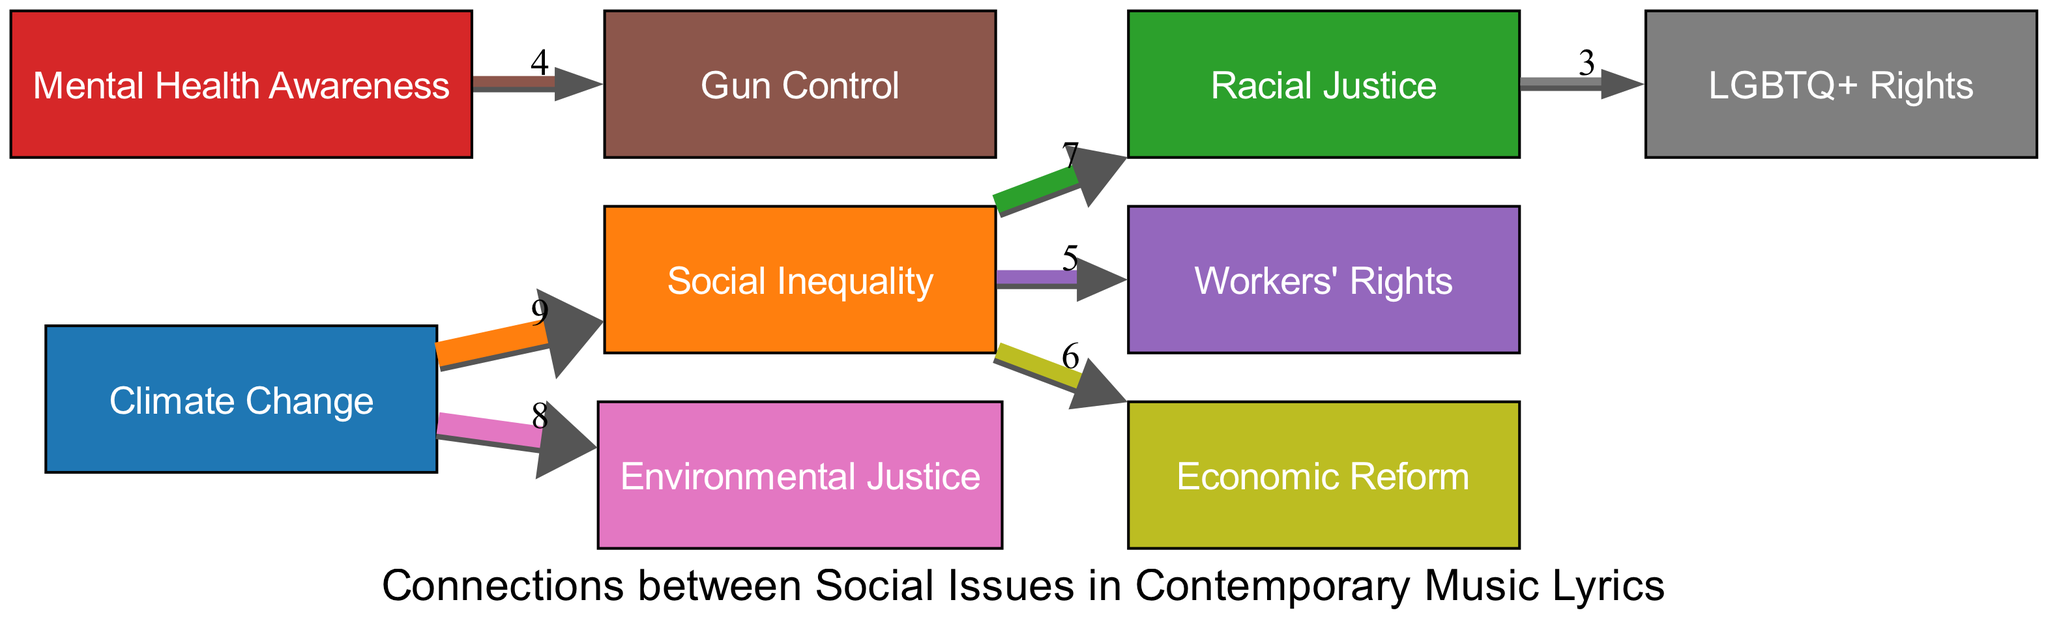What is the highest value connection in the diagram? By reviewing the links in the diagram, the connection "Climate Change" to "Social Inequality" has the highest value of 9, which indicates the most significant relationship among the social issues represented.
Answer: 9 How many nodes are represented in the diagram? Counting the nodes listed in the data, there are a total of 9 distinct social issues or nodes included in the diagram.
Answer: 9 Which issue is linked to "Gun Control"? Looking at the links, "Mental Health Awareness" connects to "Gun Control" with a value of 4, indicating a relationship between these two issues.
Answer: Mental Health Awareness What is the value of the connection between "Social Inequality" and "Racial Justice"? The link from "Social Inequality" to "Racial Justice" has a value of 7. This can be directly observed from the values associated with each connection in the diagram.
Answer: 7 Which two issues are connected with the value of 6? Examining the links, "Social Inequality" connects to "Economic Reform" with a value of 6, which is the only pair with this value.
Answer: Social Inequality and Economic Reform Which social issue connects to both "Environmental Justice" and "Social Inequality"? The node "Climate Change" is connected to "Environmental Justice" and "Social Inequality", showing its relevance to both issues through its direct links.
Answer: Climate Change What is the total number of connections (links) in the diagram? By counting the links provided in the data, there are a total of 7 connections represented in the Sankey diagram.
Answer: 7 Which social issue has the least connections according to the links? By analyzing the links, the issue "Racial Justice" connects only to "LGBTQ+ Rights" and "Social Inequality", making it less connected compared to others.
Answer: Racial Justice Which issue has a connection value of 3 in the diagram? The connection from "Racial Justice" to "LGBTQ+ Rights" has a value of 3, showing a notable link between these two social issues.
Answer: 3 